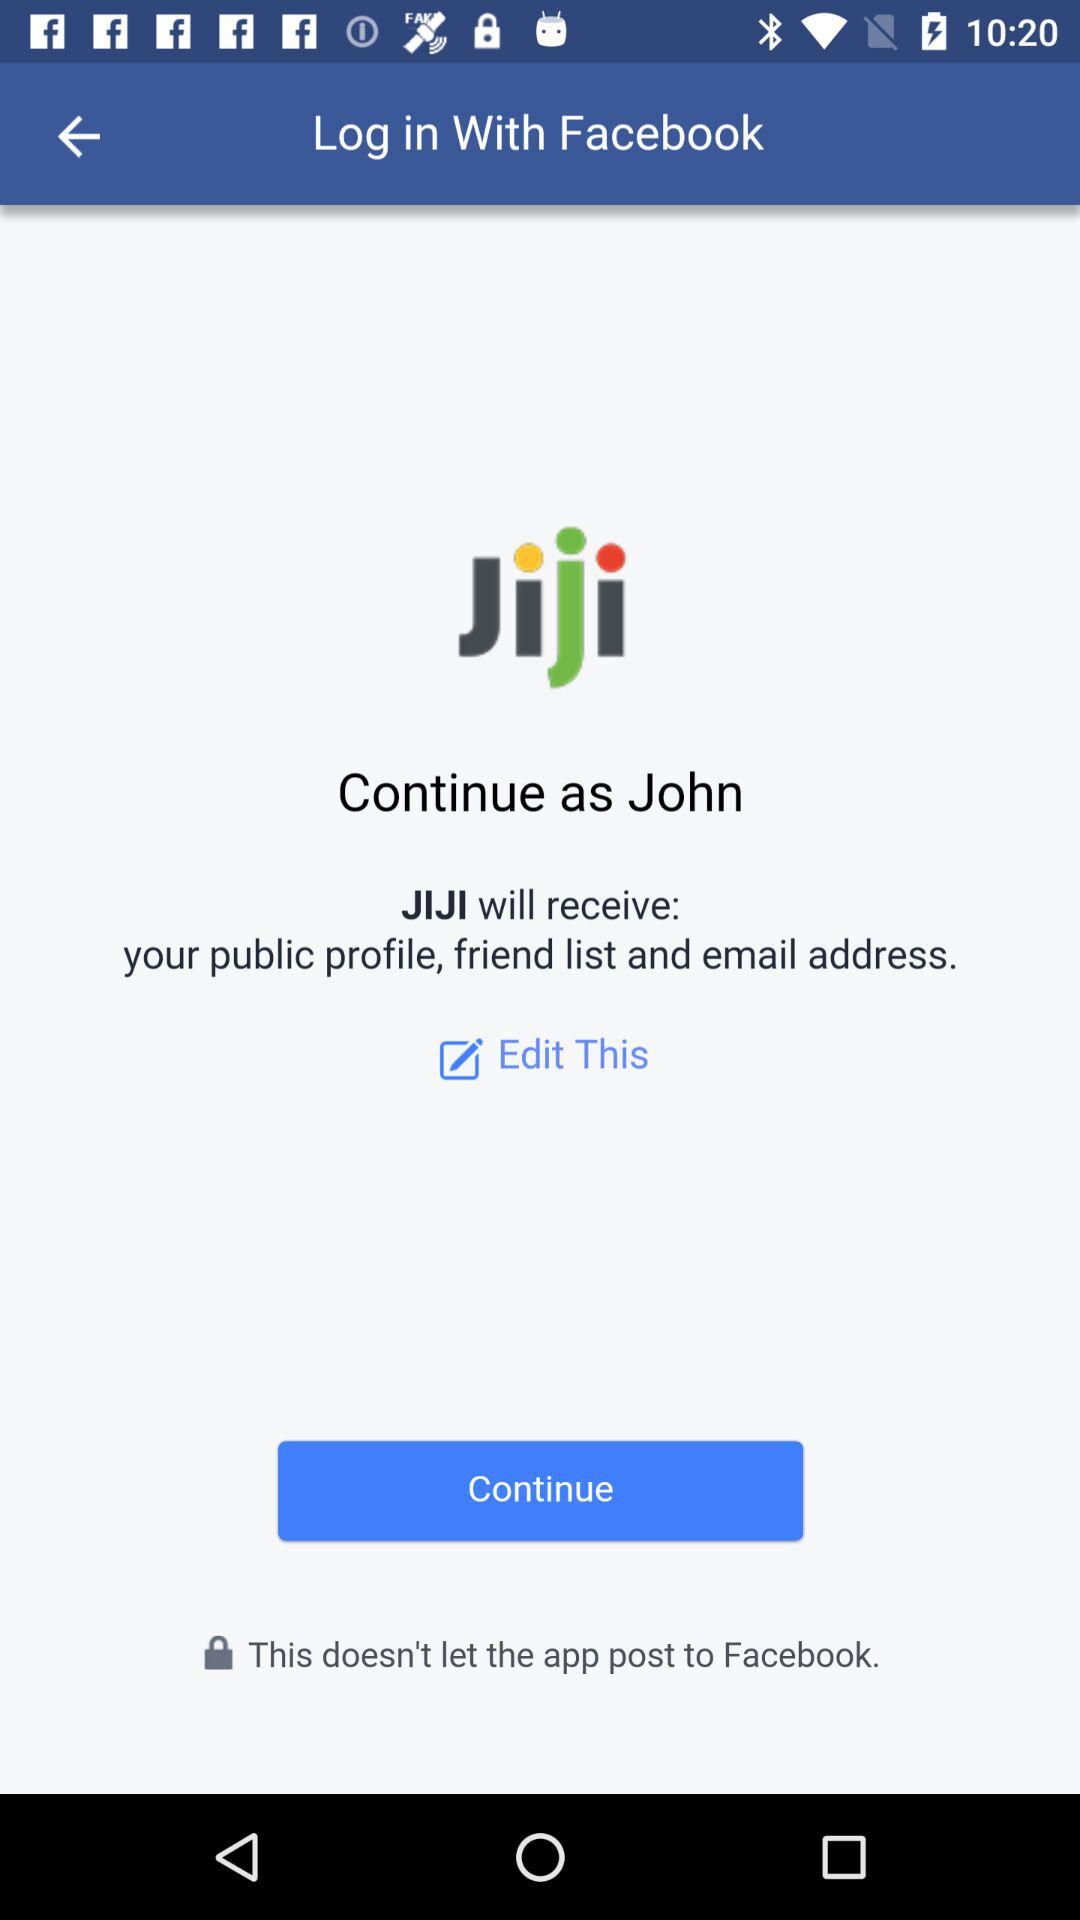What is the name of the user? The name of the user is John. 